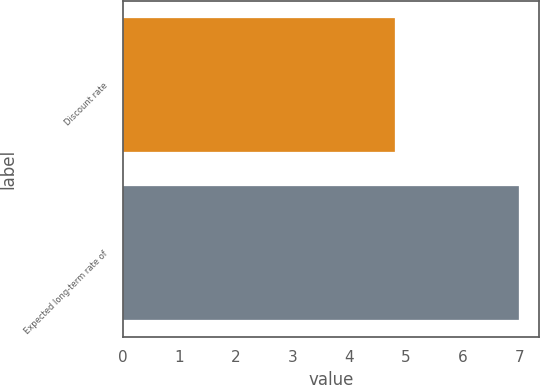Convert chart to OTSL. <chart><loc_0><loc_0><loc_500><loc_500><bar_chart><fcel>Discount rate<fcel>Expected long-term rate of<nl><fcel>4.8<fcel>7<nl></chart> 